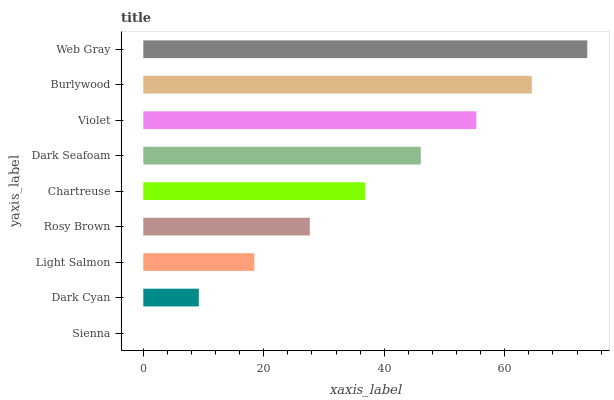Is Sienna the minimum?
Answer yes or no. Yes. Is Web Gray the maximum?
Answer yes or no. Yes. Is Dark Cyan the minimum?
Answer yes or no. No. Is Dark Cyan the maximum?
Answer yes or no. No. Is Dark Cyan greater than Sienna?
Answer yes or no. Yes. Is Sienna less than Dark Cyan?
Answer yes or no. Yes. Is Sienna greater than Dark Cyan?
Answer yes or no. No. Is Dark Cyan less than Sienna?
Answer yes or no. No. Is Chartreuse the high median?
Answer yes or no. Yes. Is Chartreuse the low median?
Answer yes or no. Yes. Is Dark Seafoam the high median?
Answer yes or no. No. Is Light Salmon the low median?
Answer yes or no. No. 